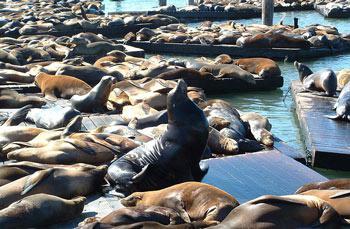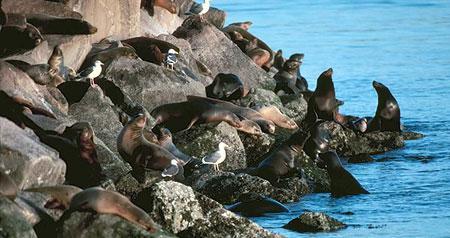The first image is the image on the left, the second image is the image on the right. For the images displayed, is the sentence "One image shows seals above the water, sharing piles of rocks with birds." factually correct? Answer yes or no. Yes. 